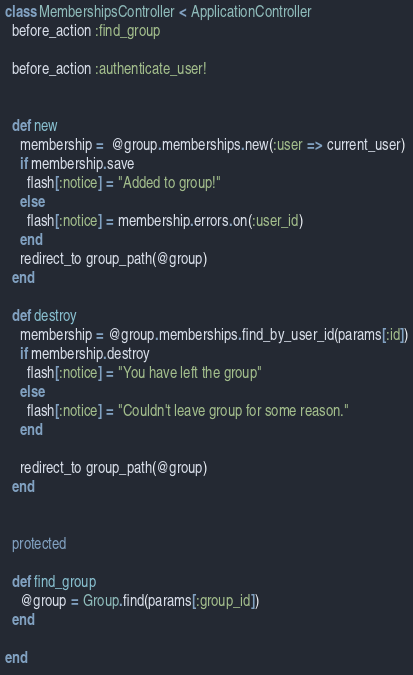Convert code to text. <code><loc_0><loc_0><loc_500><loc_500><_Ruby_>class MembershipsController < ApplicationController
  before_action :find_group

  before_action :authenticate_user!


  def new
    membership =  @group.memberships.new(:user => current_user)
    if membership.save
      flash[:notice] = "Added to group!"
    else
      flash[:notice] = membership.errors.on(:user_id)
    end
    redirect_to group_path(@group)
  end

  def destroy
    membership = @group.memberships.find_by_user_id(params[:id])
    if membership.destroy
      flash[:notice] = "You have left the group"
    else
      flash[:notice] = "Couldn't leave group for some reason."
    end

    redirect_to group_path(@group)
  end


  protected

  def find_group
    @group = Group.find(params[:group_id])
  end

end
</code> 